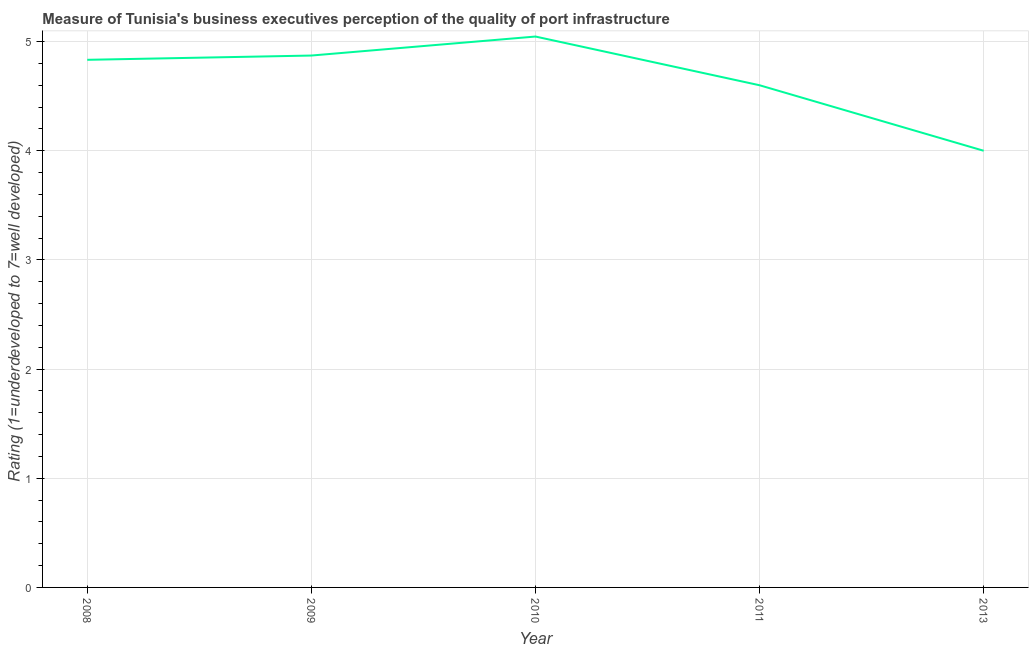What is the rating measuring quality of port infrastructure in 2009?
Provide a short and direct response. 4.87. Across all years, what is the maximum rating measuring quality of port infrastructure?
Make the answer very short. 5.05. In which year was the rating measuring quality of port infrastructure maximum?
Offer a terse response. 2010. What is the sum of the rating measuring quality of port infrastructure?
Offer a terse response. 23.35. What is the difference between the rating measuring quality of port infrastructure in 2008 and 2011?
Ensure brevity in your answer.  0.23. What is the average rating measuring quality of port infrastructure per year?
Keep it short and to the point. 4.67. What is the median rating measuring quality of port infrastructure?
Ensure brevity in your answer.  4.83. Do a majority of the years between 2013 and 2010 (inclusive) have rating measuring quality of port infrastructure greater than 1 ?
Provide a short and direct response. No. What is the ratio of the rating measuring quality of port infrastructure in 2008 to that in 2009?
Give a very brief answer. 0.99. What is the difference between the highest and the second highest rating measuring quality of port infrastructure?
Your response must be concise. 0.17. What is the difference between the highest and the lowest rating measuring quality of port infrastructure?
Keep it short and to the point. 1.05. In how many years, is the rating measuring quality of port infrastructure greater than the average rating measuring quality of port infrastructure taken over all years?
Your answer should be compact. 3. Are the values on the major ticks of Y-axis written in scientific E-notation?
Ensure brevity in your answer.  No. What is the title of the graph?
Provide a short and direct response. Measure of Tunisia's business executives perception of the quality of port infrastructure. What is the label or title of the X-axis?
Make the answer very short. Year. What is the label or title of the Y-axis?
Your answer should be very brief. Rating (1=underdeveloped to 7=well developed) . What is the Rating (1=underdeveloped to 7=well developed)  of 2008?
Keep it short and to the point. 4.83. What is the Rating (1=underdeveloped to 7=well developed)  in 2009?
Make the answer very short. 4.87. What is the Rating (1=underdeveloped to 7=well developed)  of 2010?
Your response must be concise. 5.05. What is the Rating (1=underdeveloped to 7=well developed)  of 2011?
Offer a very short reply. 4.6. What is the difference between the Rating (1=underdeveloped to 7=well developed)  in 2008 and 2009?
Offer a very short reply. -0.04. What is the difference between the Rating (1=underdeveloped to 7=well developed)  in 2008 and 2010?
Your response must be concise. -0.21. What is the difference between the Rating (1=underdeveloped to 7=well developed)  in 2008 and 2011?
Your response must be concise. 0.23. What is the difference between the Rating (1=underdeveloped to 7=well developed)  in 2008 and 2013?
Your answer should be very brief. 0.83. What is the difference between the Rating (1=underdeveloped to 7=well developed)  in 2009 and 2010?
Your answer should be very brief. -0.17. What is the difference between the Rating (1=underdeveloped to 7=well developed)  in 2009 and 2011?
Offer a terse response. 0.27. What is the difference between the Rating (1=underdeveloped to 7=well developed)  in 2009 and 2013?
Offer a very short reply. 0.87. What is the difference between the Rating (1=underdeveloped to 7=well developed)  in 2010 and 2011?
Make the answer very short. 0.45. What is the difference between the Rating (1=underdeveloped to 7=well developed)  in 2010 and 2013?
Offer a very short reply. 1.05. What is the ratio of the Rating (1=underdeveloped to 7=well developed)  in 2008 to that in 2010?
Give a very brief answer. 0.96. What is the ratio of the Rating (1=underdeveloped to 7=well developed)  in 2008 to that in 2011?
Make the answer very short. 1.05. What is the ratio of the Rating (1=underdeveloped to 7=well developed)  in 2008 to that in 2013?
Provide a short and direct response. 1.21. What is the ratio of the Rating (1=underdeveloped to 7=well developed)  in 2009 to that in 2011?
Ensure brevity in your answer.  1.06. What is the ratio of the Rating (1=underdeveloped to 7=well developed)  in 2009 to that in 2013?
Offer a terse response. 1.22. What is the ratio of the Rating (1=underdeveloped to 7=well developed)  in 2010 to that in 2011?
Provide a short and direct response. 1.1. What is the ratio of the Rating (1=underdeveloped to 7=well developed)  in 2010 to that in 2013?
Give a very brief answer. 1.26. What is the ratio of the Rating (1=underdeveloped to 7=well developed)  in 2011 to that in 2013?
Offer a very short reply. 1.15. 